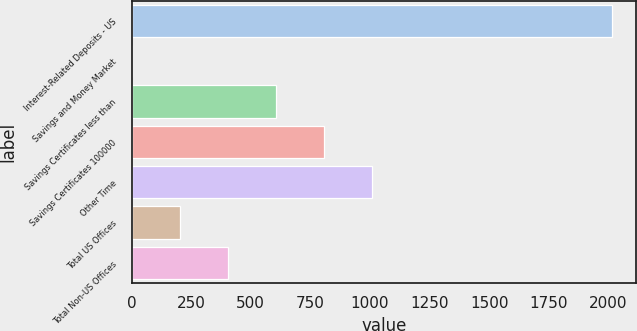<chart> <loc_0><loc_0><loc_500><loc_500><bar_chart><fcel>Interest-Related Deposits - US<fcel>Savings and Money Market<fcel>Savings Certificates less than<fcel>Savings Certificates 100000<fcel>Other Time<fcel>Total US Offices<fcel>Total Non-US Offices<nl><fcel>2015<fcel>0.06<fcel>604.53<fcel>806.02<fcel>1007.51<fcel>201.55<fcel>403.04<nl></chart> 